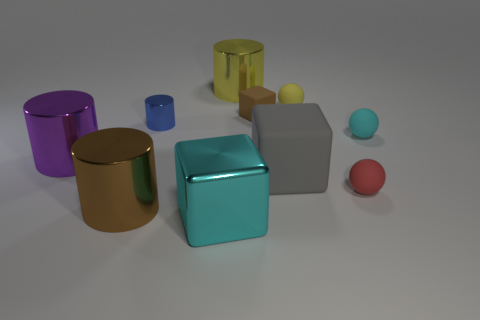Subtract 1 cylinders. How many cylinders are left? 3 Subtract all gray cylinders. Subtract all green balls. How many cylinders are left? 4 Subtract all cubes. How many objects are left? 7 Subtract 0 blue balls. How many objects are left? 10 Subtract all brown matte objects. Subtract all cyan shiny blocks. How many objects are left? 8 Add 4 tiny spheres. How many tiny spheres are left? 7 Add 4 purple metallic objects. How many purple metallic objects exist? 5 